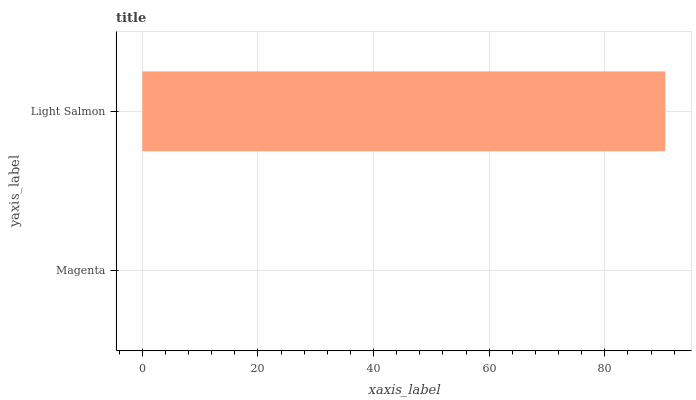Is Magenta the minimum?
Answer yes or no. Yes. Is Light Salmon the maximum?
Answer yes or no. Yes. Is Light Salmon the minimum?
Answer yes or no. No. Is Light Salmon greater than Magenta?
Answer yes or no. Yes. Is Magenta less than Light Salmon?
Answer yes or no. Yes. Is Magenta greater than Light Salmon?
Answer yes or no. No. Is Light Salmon less than Magenta?
Answer yes or no. No. Is Light Salmon the high median?
Answer yes or no. Yes. Is Magenta the low median?
Answer yes or no. Yes. Is Magenta the high median?
Answer yes or no. No. Is Light Salmon the low median?
Answer yes or no. No. 